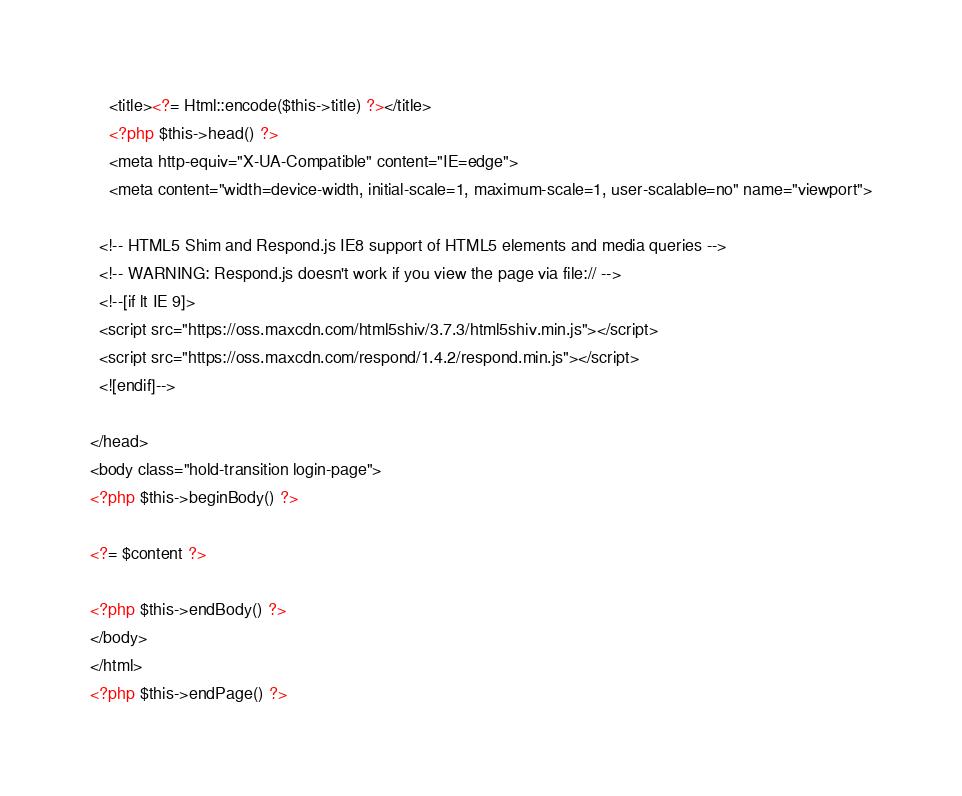Convert code to text. <code><loc_0><loc_0><loc_500><loc_500><_PHP_>    <title><?= Html::encode($this->title) ?></title>
    <?php $this->head() ?>
    <meta http-equiv="X-UA-Compatible" content="IE=edge">  
    <meta content="width=device-width, initial-scale=1, maximum-scale=1, user-scalable=no" name="viewport">
  
  <!-- HTML5 Shim and Respond.js IE8 support of HTML5 elements and media queries -->
  <!-- WARNING: Respond.js doesn't work if you view the page via file:// -->
  <!--[if lt IE 9]>
  <script src="https://oss.maxcdn.com/html5shiv/3.7.3/html5shiv.min.js"></script>
  <script src="https://oss.maxcdn.com/respond/1.4.2/respond.min.js"></script>
  <![endif]-->

</head>
<body class="hold-transition login-page">
<?php $this->beginBody() ?>

<?= $content ?>

<?php $this->endBody() ?>
</body>
</html>
<?php $this->endPage() ?>
</code> 